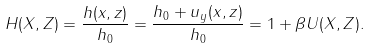<formula> <loc_0><loc_0><loc_500><loc_500>H ( X , Z ) = \frac { h ( x , z ) } { h _ { 0 } } = \frac { h _ { 0 } + u _ { y } ( x , z ) } { h _ { 0 } } = 1 + \beta U ( X , Z ) .</formula> 